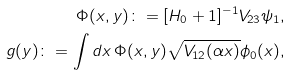Convert formula to latex. <formula><loc_0><loc_0><loc_500><loc_500>\Phi ( x , y ) \colon = [ H _ { 0 } + 1 ] ^ { - 1 } V _ { 2 3 } \psi _ { 1 } , \\ g ( y ) \colon = \int d x \, \Phi ( x , y ) \sqrt { V _ { 1 2 } ( \alpha x ) } \phi _ { 0 } ( x ) ,</formula> 